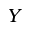Convert formula to latex. <formula><loc_0><loc_0><loc_500><loc_500>Y</formula> 